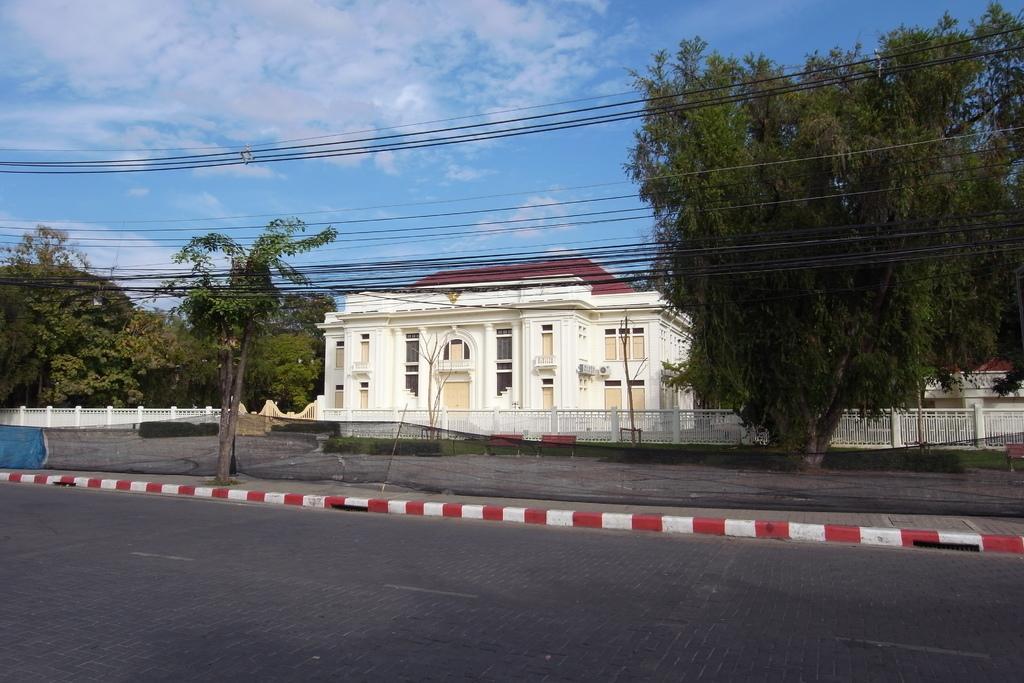Can you describe this image briefly? This is a building with the windows. I can see a black cloth hanging. These are the trees. This looks like a road. I can see a pathway. I think this is a barricade. There are two benches. I can see the clouds in the sky. These are the current wires. 